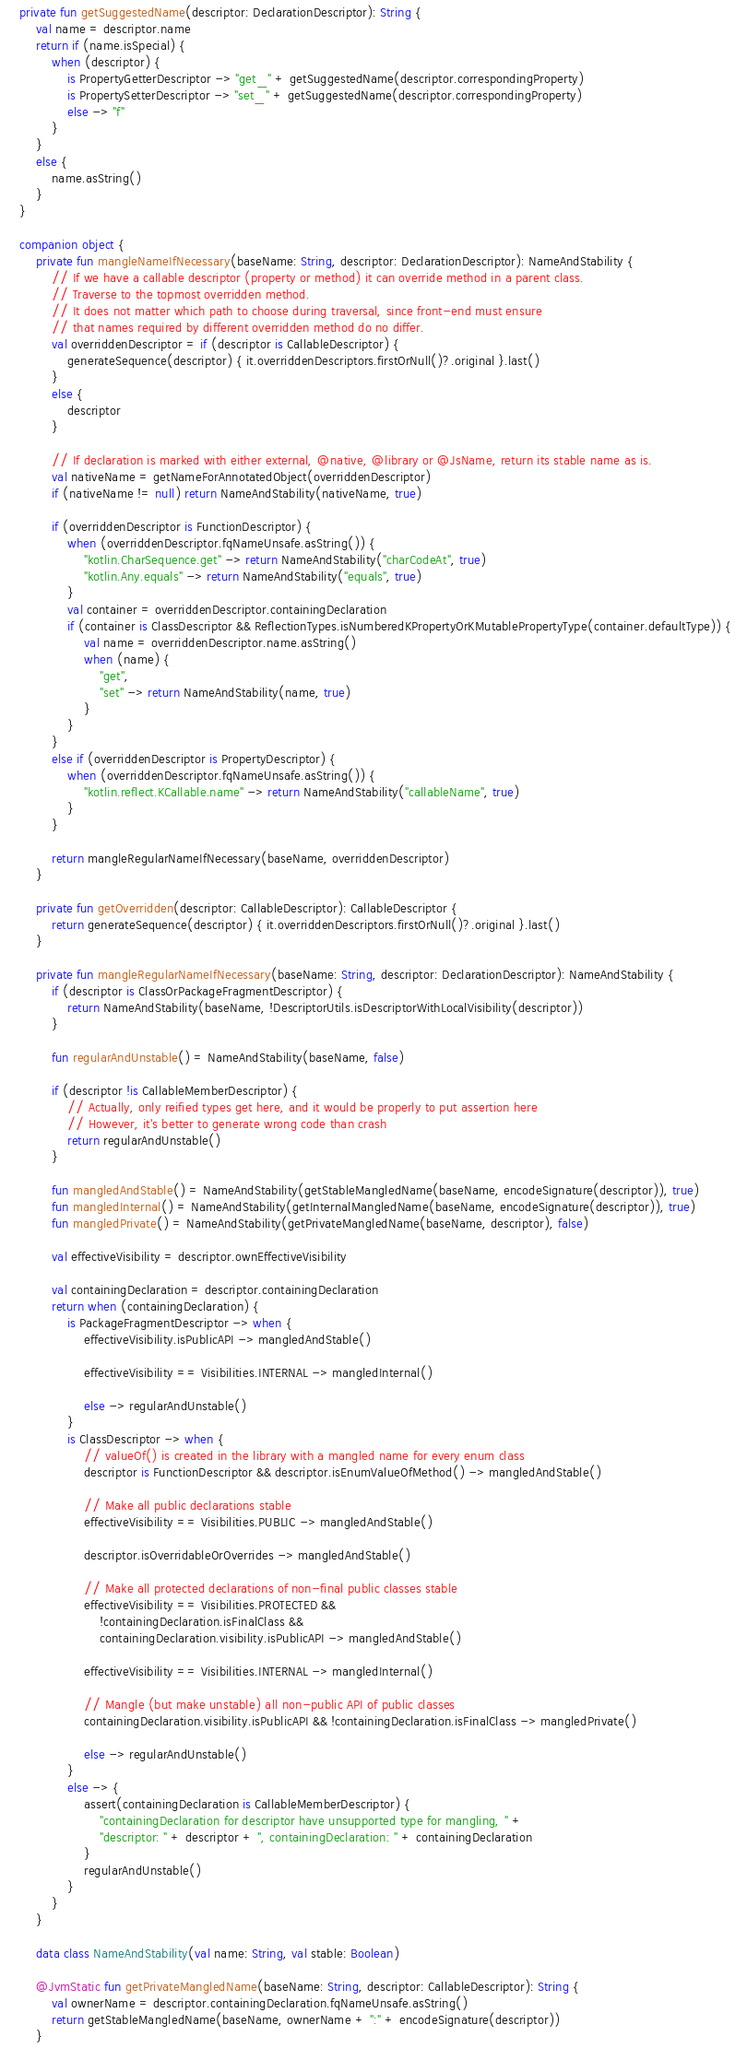Convert code to text. <code><loc_0><loc_0><loc_500><loc_500><_Kotlin_>    private fun getSuggestedName(descriptor: DeclarationDescriptor): String {
        val name = descriptor.name
        return if (name.isSpecial) {
            when (descriptor) {
                is PropertyGetterDescriptor -> "get_" + getSuggestedName(descriptor.correspondingProperty)
                is PropertySetterDescriptor -> "set_" + getSuggestedName(descriptor.correspondingProperty)
                else -> "f"
            }
        }
        else {
            name.asString()
        }
    }

    companion object {
        private fun mangleNameIfNecessary(baseName: String, descriptor: DeclarationDescriptor): NameAndStability {
            // If we have a callable descriptor (property or method) it can override method in a parent class.
            // Traverse to the topmost overridden method.
            // It does not matter which path to choose during traversal, since front-end must ensure
            // that names required by different overridden method do no differ.
            val overriddenDescriptor = if (descriptor is CallableDescriptor) {
                generateSequence(descriptor) { it.overriddenDescriptors.firstOrNull()?.original }.last()
            }
            else {
                descriptor
            }

            // If declaration is marked with either external, @native, @library or @JsName, return its stable name as is.
            val nativeName = getNameForAnnotatedObject(overriddenDescriptor)
            if (nativeName != null) return NameAndStability(nativeName, true)

            if (overriddenDescriptor is FunctionDescriptor) {
                when (overriddenDescriptor.fqNameUnsafe.asString()) {
                    "kotlin.CharSequence.get" -> return NameAndStability("charCodeAt", true)
                    "kotlin.Any.equals" -> return NameAndStability("equals", true)
                }
                val container = overriddenDescriptor.containingDeclaration
                if (container is ClassDescriptor && ReflectionTypes.isNumberedKPropertyOrKMutablePropertyType(container.defaultType)) {
                    val name = overriddenDescriptor.name.asString()
                    when (name) {
                        "get",
                        "set" -> return NameAndStability(name, true)
                    }
                }
            }
            else if (overriddenDescriptor is PropertyDescriptor) {
                when (overriddenDescriptor.fqNameUnsafe.asString()) {
                    "kotlin.reflect.KCallable.name" -> return NameAndStability("callableName", true)
                }
            }

            return mangleRegularNameIfNecessary(baseName, overriddenDescriptor)
        }

        private fun getOverridden(descriptor: CallableDescriptor): CallableDescriptor {
            return generateSequence(descriptor) { it.overriddenDescriptors.firstOrNull()?.original }.last()
        }

        private fun mangleRegularNameIfNecessary(baseName: String, descriptor: DeclarationDescriptor): NameAndStability {
            if (descriptor is ClassOrPackageFragmentDescriptor) {
                return NameAndStability(baseName, !DescriptorUtils.isDescriptorWithLocalVisibility(descriptor))
            }

            fun regularAndUnstable() = NameAndStability(baseName, false)

            if (descriptor !is CallableMemberDescriptor) {
                // Actually, only reified types get here, and it would be properly to put assertion here
                // However, it's better to generate wrong code than crash
                return regularAndUnstable()
            }

            fun mangledAndStable() = NameAndStability(getStableMangledName(baseName, encodeSignature(descriptor)), true)
            fun mangledInternal() = NameAndStability(getInternalMangledName(baseName, encodeSignature(descriptor)), true)
            fun mangledPrivate() = NameAndStability(getPrivateMangledName(baseName, descriptor), false)

            val effectiveVisibility = descriptor.ownEffectiveVisibility

            val containingDeclaration = descriptor.containingDeclaration
            return when (containingDeclaration) {
                is PackageFragmentDescriptor -> when {
                    effectiveVisibility.isPublicAPI -> mangledAndStable()

                    effectiveVisibility == Visibilities.INTERNAL -> mangledInternal()

                    else -> regularAndUnstable()
                }
                is ClassDescriptor -> when {
                    // valueOf() is created in the library with a mangled name for every enum class
                    descriptor is FunctionDescriptor && descriptor.isEnumValueOfMethod() -> mangledAndStable()

                    // Make all public declarations stable
                    effectiveVisibility == Visibilities.PUBLIC -> mangledAndStable()

                    descriptor.isOverridableOrOverrides -> mangledAndStable()

                    // Make all protected declarations of non-final public classes stable
                    effectiveVisibility == Visibilities.PROTECTED &&
                        !containingDeclaration.isFinalClass &&
                        containingDeclaration.visibility.isPublicAPI -> mangledAndStable()

                    effectiveVisibility == Visibilities.INTERNAL -> mangledInternal()

                    // Mangle (but make unstable) all non-public API of public classes
                    containingDeclaration.visibility.isPublicAPI && !containingDeclaration.isFinalClass -> mangledPrivate()

                    else -> regularAndUnstable()
                }
                else -> {
                    assert(containingDeclaration is CallableMemberDescriptor) {
                        "containingDeclaration for descriptor have unsupported type for mangling, " +
                        "descriptor: " + descriptor + ", containingDeclaration: " + containingDeclaration
                    }
                    regularAndUnstable()
                }
            }
        }

        data class NameAndStability(val name: String, val stable: Boolean)

        @JvmStatic fun getPrivateMangledName(baseName: String, descriptor: CallableDescriptor): String {
            val ownerName = descriptor.containingDeclaration.fqNameUnsafe.asString()
            return getStableMangledName(baseName, ownerName + ":" + encodeSignature(descriptor))
        }
</code> 